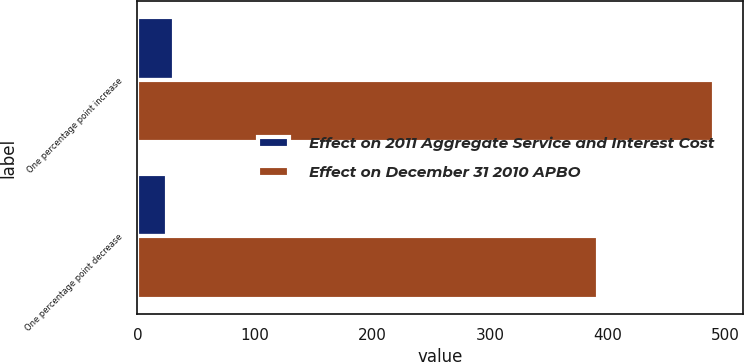Convert chart. <chart><loc_0><loc_0><loc_500><loc_500><stacked_bar_chart><ecel><fcel>One percentage point increase<fcel>One percentage point decrease<nl><fcel>Effect on 2011 Aggregate Service and Interest Cost<fcel>31<fcel>25<nl><fcel>Effect on December 31 2010 APBO<fcel>491<fcel>392<nl></chart> 